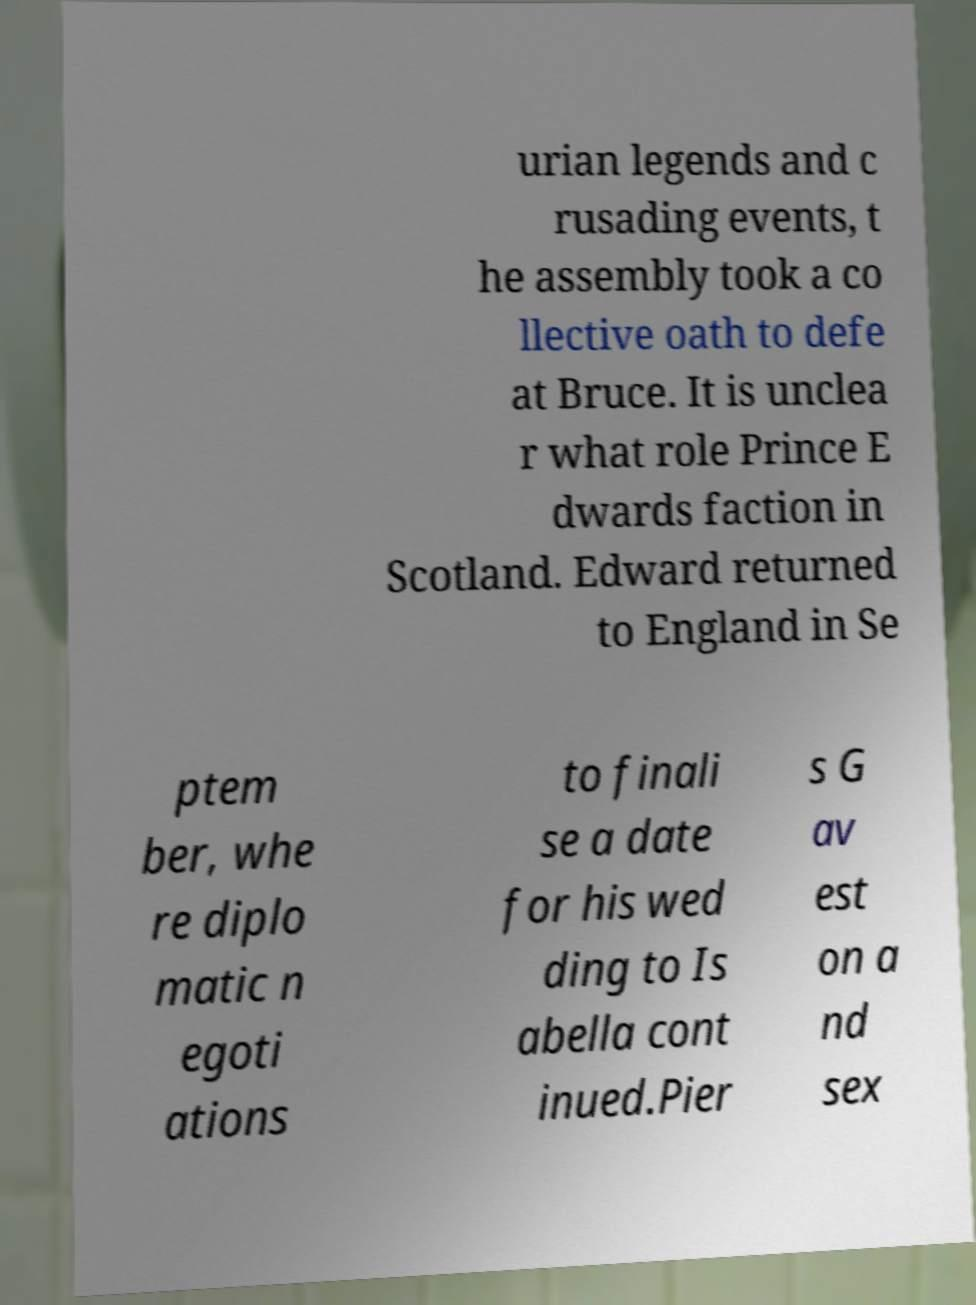Could you extract and type out the text from this image? urian legends and c rusading events, t he assembly took a co llective oath to defe at Bruce. It is unclea r what role Prince E dwards faction in Scotland. Edward returned to England in Se ptem ber, whe re diplo matic n egoti ations to finali se a date for his wed ding to Is abella cont inued.Pier s G av est on a nd sex 